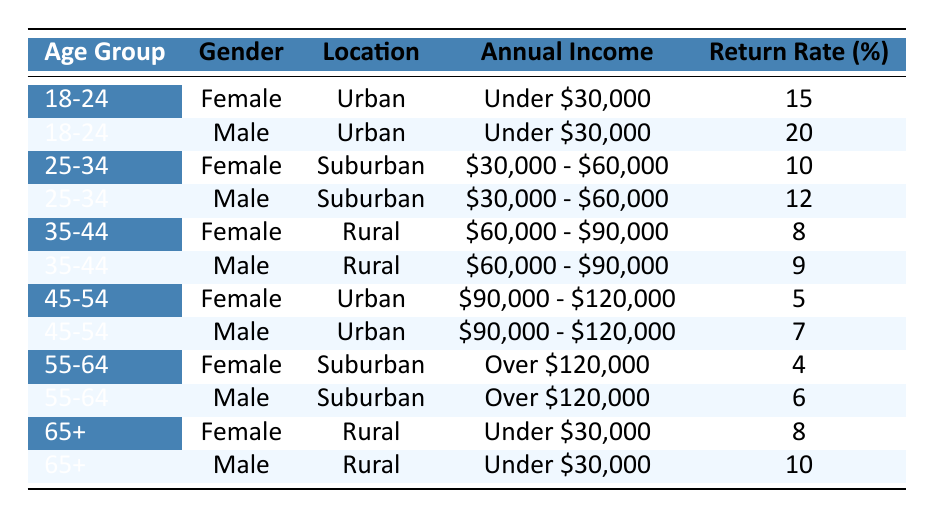What is the return rate for females in the age group 18-24? From the table, the data shows that for females in the age group 18-24, the return rate percentage is 15.
Answer: 15 What is the return rate for males aged 25-34 living in suburban areas? The table indicates that the return rate for males in the age group 25-34 who live in suburban areas is 12.
Answer: 12 Are the return rates higher for urban males or urban females in the age group 45-54? For urban males aged 45-54, the return rate is 7, while for urban females in the same age group, it is 5. Therefore, urban males have a higher return rate than urban females.
Answer: Yes What is the average return rate for males across all age groups? The return rates for males are: 20 (18-24) + 12 (25-34) + 9 (35-44) + 7 (45-54) + 6 (55-64) + 10 (65+) = 64. Since there are 6 data points, the average is 64/6 = 10.67.
Answer: 10.67 Is there any age group that has a higher return rate for females than for males when considering the 35-44 age group? In the 35-44 age group, the return rate for females is 8 and for males is 9. Since 8 is less than 9, there is no age group where females have a higher return rate than males in that category.
Answer: No What is the total return rate percentage for all customers in the age group 55-64? The return rates for the age group 55-64 are: 4 (female) + 6 (male) = 10. The total return rate percentage for this age group is 10.
Answer: 10 Which demographic group has the highest return rate percentage? Looking through the table, the highest return rate percentage is 20 for urban males aged 18-24.
Answer: 20 What is the difference in return rates between the age groups 25-34 and 35-44 for females? The return rate for females aged 25-34 is 10, while for those aged 35-44 it is 8. The difference is 10 - 8 = 2.
Answer: 2 Which demographic group has the lowest return rate percentage? In the table, the lowest return rate percentage is 4 for females aged 55-64.
Answer: 4 